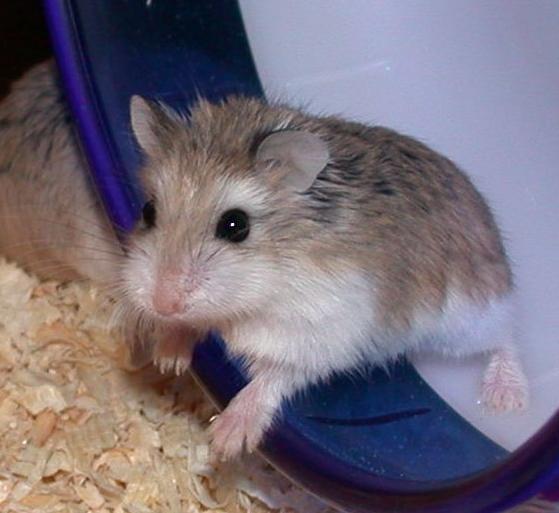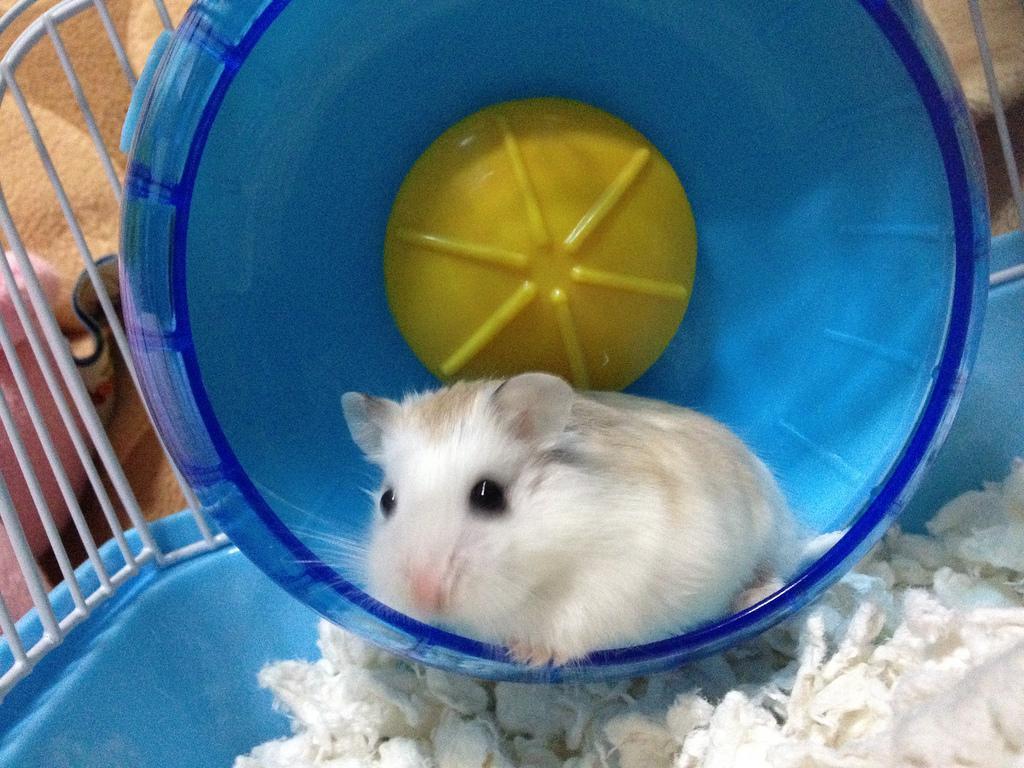The first image is the image on the left, the second image is the image on the right. For the images shown, is this caption "Each image shows exactly two rodents." true? Answer yes or no. No. The first image is the image on the left, the second image is the image on the right. For the images shown, is this caption "Every hamster is inside a wheel, and every hamster wheel is bright blue." true? Answer yes or no. Yes. 